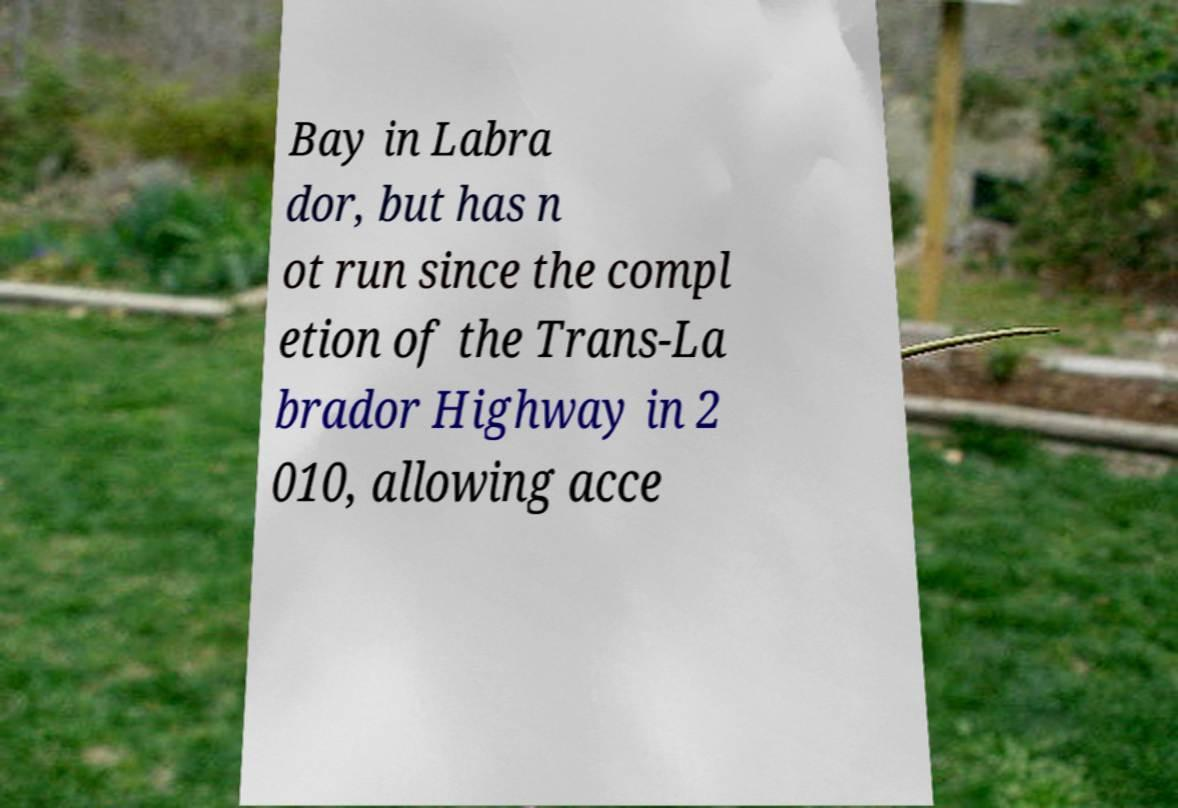I need the written content from this picture converted into text. Can you do that? Bay in Labra dor, but has n ot run since the compl etion of the Trans-La brador Highway in 2 010, allowing acce 